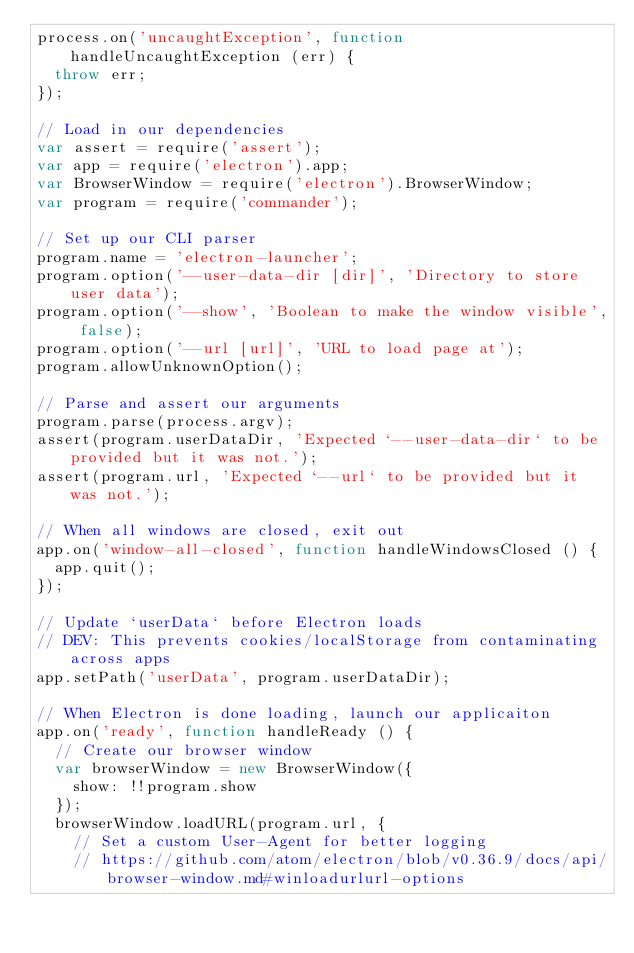<code> <loc_0><loc_0><loc_500><loc_500><_JavaScript_>process.on('uncaughtException', function handleUncaughtException (err) {
  throw err;
});

// Load in our dependencies
var assert = require('assert');
var app = require('electron').app;
var BrowserWindow = require('electron').BrowserWindow;
var program = require('commander');

// Set up our CLI parser
program.name = 'electron-launcher';
program.option('--user-data-dir [dir]', 'Directory to store user data');
program.option('--show', 'Boolean to make the window visible', false);
program.option('--url [url]', 'URL to load page at');
program.allowUnknownOption();

// Parse and assert our arguments
program.parse(process.argv);
assert(program.userDataDir, 'Expected `--user-data-dir` to be provided but it was not.');
assert(program.url, 'Expected `--url` to be provided but it was not.');

// When all windows are closed, exit out
app.on('window-all-closed', function handleWindowsClosed () {
  app.quit();
});

// Update `userData` before Electron loads
// DEV: This prevents cookies/localStorage from contaminating across apps
app.setPath('userData', program.userDataDir);

// When Electron is done loading, launch our applicaiton
app.on('ready', function handleReady () {
  // Create our browser window
  var browserWindow = new BrowserWindow({
    show: !!program.show
  });
  browserWindow.loadURL(program.url, {
    // Set a custom User-Agent for better logging
    // https://github.com/atom/electron/blob/v0.36.9/docs/api/browser-window.md#winloadurlurl-options</code> 